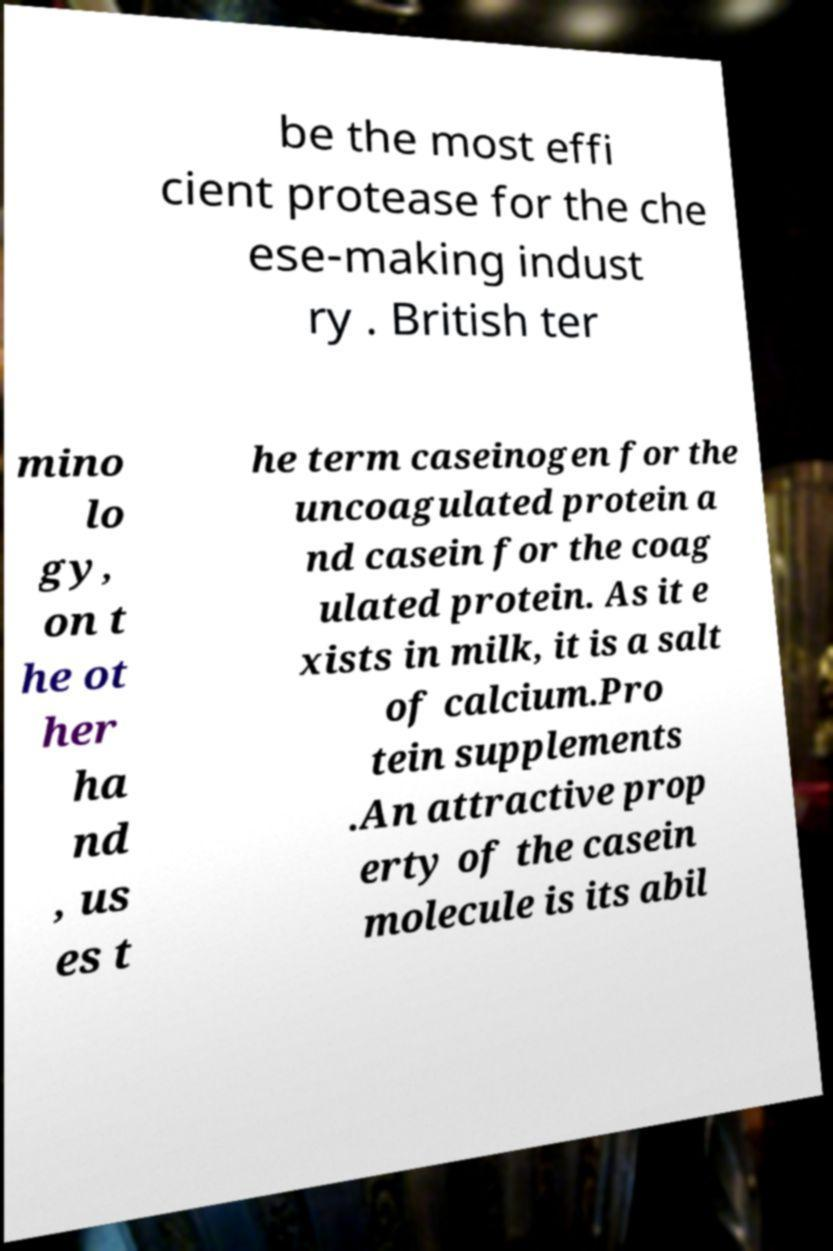There's text embedded in this image that I need extracted. Can you transcribe it verbatim? be the most effi cient protease for the che ese-making indust ry . British ter mino lo gy, on t he ot her ha nd , us es t he term caseinogen for the uncoagulated protein a nd casein for the coag ulated protein. As it e xists in milk, it is a salt of calcium.Pro tein supplements .An attractive prop erty of the casein molecule is its abil 